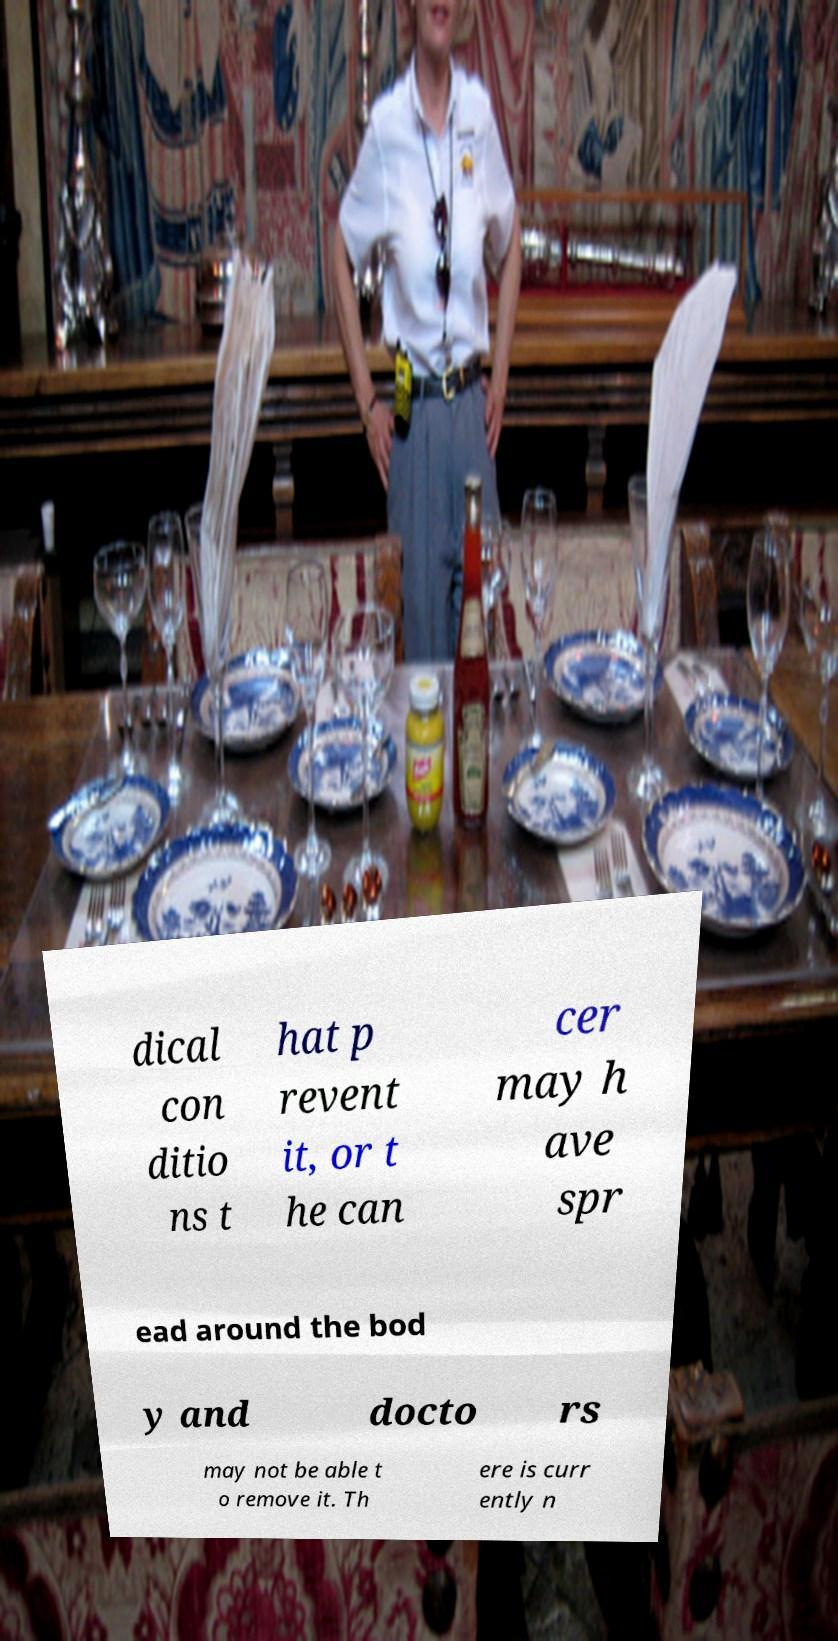I need the written content from this picture converted into text. Can you do that? dical con ditio ns t hat p revent it, or t he can cer may h ave spr ead around the bod y and docto rs may not be able t o remove it. Th ere is curr ently n 